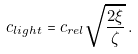Convert formula to latex. <formula><loc_0><loc_0><loc_500><loc_500>c _ { l i g h t } = c _ { r e l } \sqrt { \frac { 2 \xi } { \zeta } } \, .</formula> 